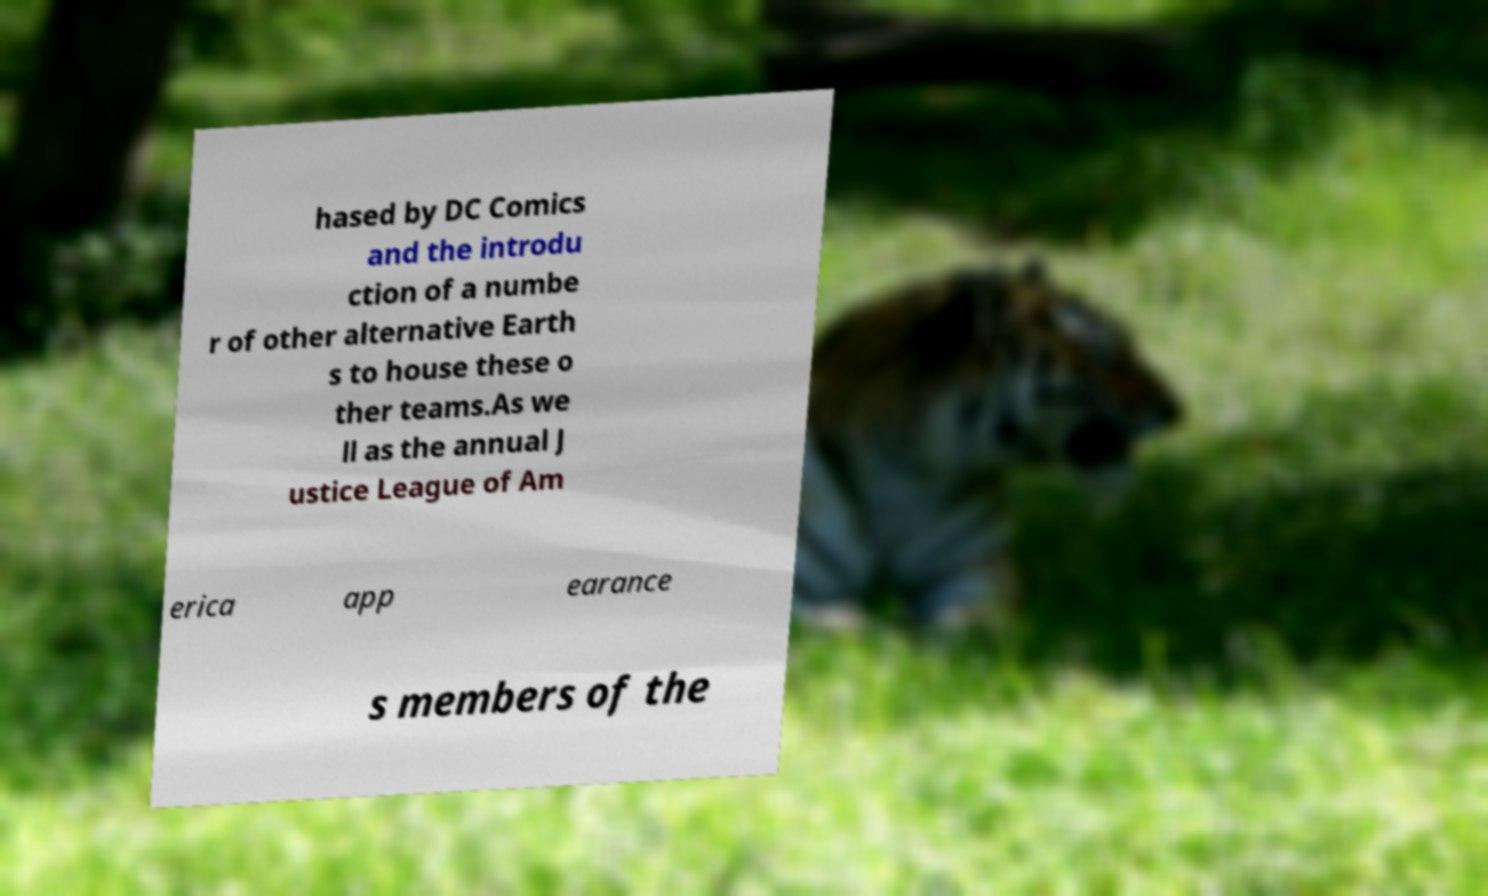Could you assist in decoding the text presented in this image and type it out clearly? hased by DC Comics and the introdu ction of a numbe r of other alternative Earth s to house these o ther teams.As we ll as the annual J ustice League of Am erica app earance s members of the 